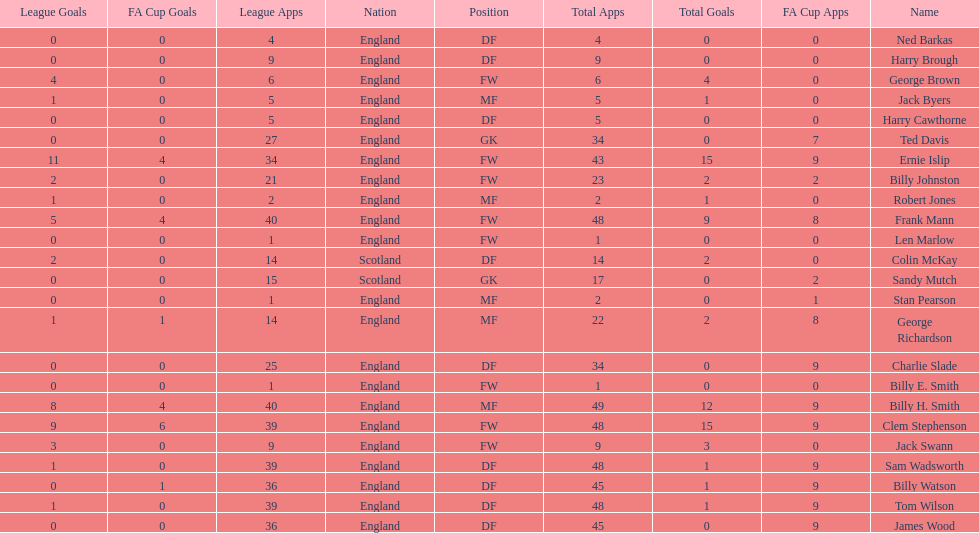The least number of total appearances 1. 